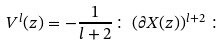<formula> <loc_0><loc_0><loc_500><loc_500>V ^ { l } ( z ) = - \frac { 1 } { l + 2 } \colon \, ( \partial X ( z ) ) ^ { l + 2 } \, \colon</formula> 